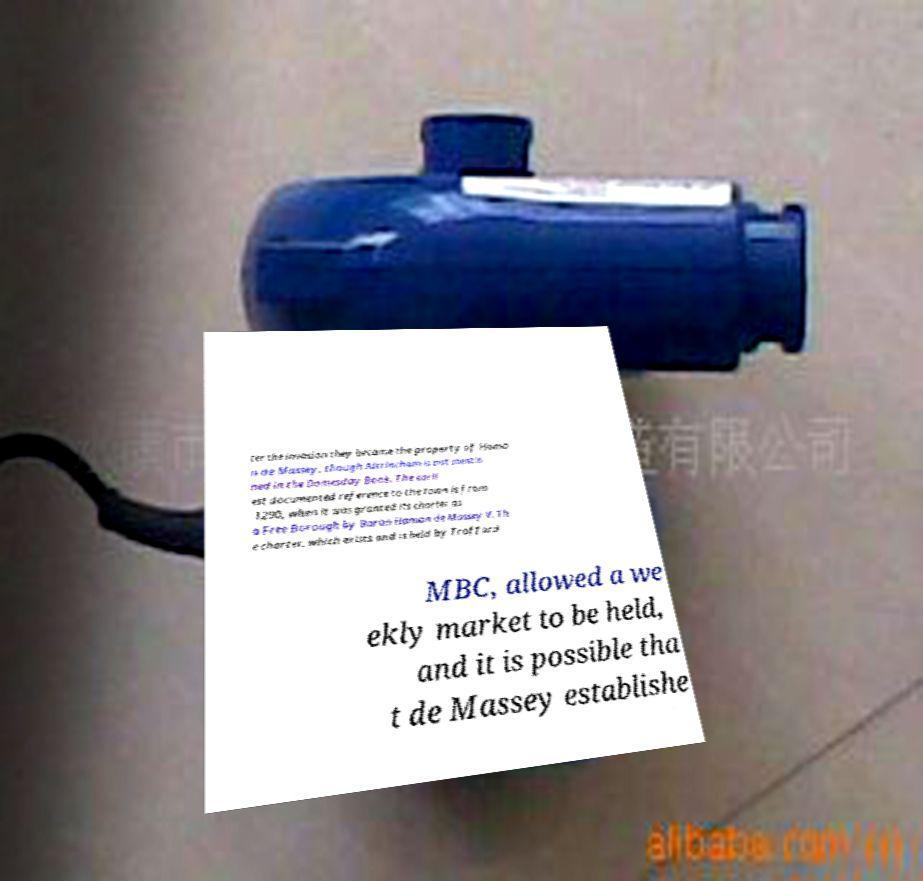I need the written content from this picture converted into text. Can you do that? ter the invasion they became the property of Hamo n de Massey, though Altrincham is not mentio ned in the Domesday Book. The earli est documented reference to the town is from 1290, when it was granted its charter as a Free Borough by Baron Hamon de Massey V. Th e charter, which exists and is held by Trafford MBC, allowed a we ekly market to be held, and it is possible tha t de Massey establishe 